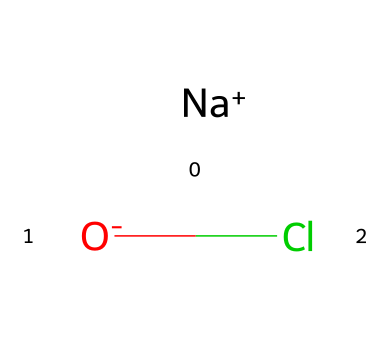what is the molecular formula of sodium hypochlorite? The SMILES representation indicates that sodium hypochlorite consists of one sodium atom (Na), one oxygen atom (O), and one chlorine atom (Cl). Therefore, the molecular formula is NaClO.
Answer: NaClO how many total atoms are present in sodium hypochlorite? In sodium hypochlorite, there are three different types of atoms: one sodium (Na), one oxygen (O), and one chlorine (Cl), which totals three atoms.
Answer: 3 which element in sodium hypochlorite is responsible for its disinfectant properties? Sodium hypochlorite contains chlorine, which is known for its strong oxidizing properties and ability to kill bacteria and viruses, making it effective as a disinfectant.
Answer: chlorine is sodium hypochlorite an ionic compound? The presence of charged species ([Na+] and [O-]), indicates that sodium hypochlorite is formed from ions, characteristic of ionic compounds.
Answer: yes what charge does the sodium ion have in sodium hypochlorite? The sodium ion is represented as [Na+], indicating that it has a positive charge.
Answer: positive which part of sodium hypochlorite contributes to its corrosive nature? The hypochlorite ion (OCl-) formed from chlorine and oxygen is responsible for the corrosive nature of sodium hypochlorite when it reacts with organic materials.
Answer: hypochlorite ion 